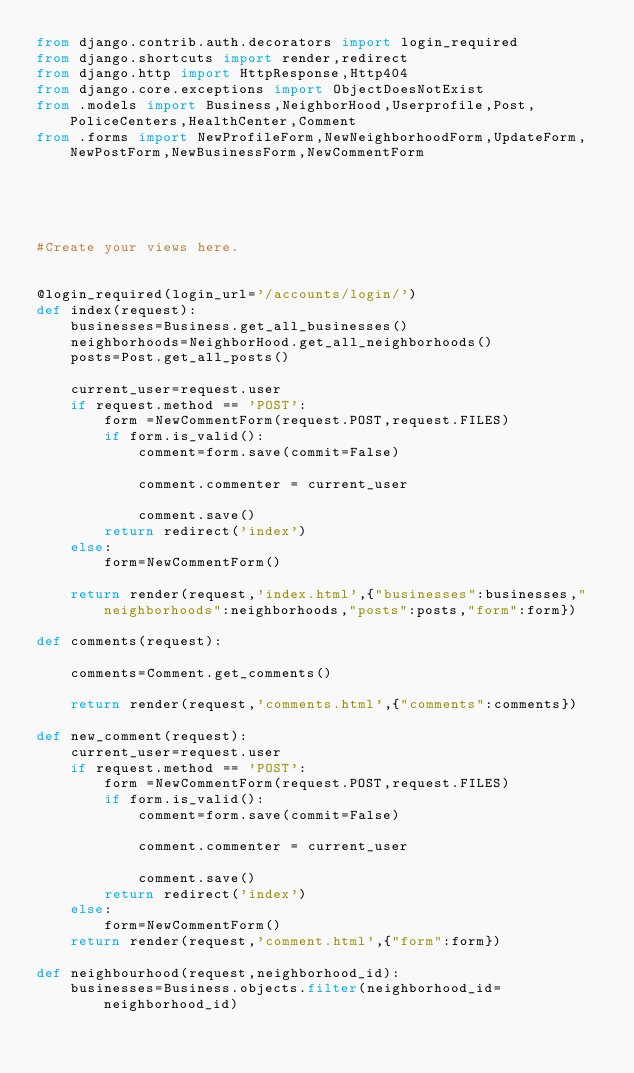<code> <loc_0><loc_0><loc_500><loc_500><_Python_>from django.contrib.auth.decorators import login_required
from django.shortcuts import render,redirect
from django.http import HttpResponse,Http404
from django.core.exceptions import ObjectDoesNotExist
from .models import Business,NeighborHood,Userprofile,Post,PoliceCenters,HealthCenter,Comment
from .forms import NewProfileForm,NewNeighborhoodForm,UpdateForm,NewPostForm,NewBusinessForm,NewCommentForm





#Create your views here.


@login_required(login_url='/accounts/login/')
def index(request):
    businesses=Business.get_all_businesses()
    neighborhoods=NeighborHood.get_all_neighborhoods()
    posts=Post.get_all_posts()

    current_user=request.user
    if request.method == 'POST':
        form =NewCommentForm(request.POST,request.FILES)
        if form.is_valid():
            comment=form.save(commit=False)

            comment.commenter = current_user

            comment.save()
        return redirect('index')
    else:
        form=NewCommentForm()

    return render(request,'index.html',{"businesses":businesses,"neighborhoods":neighborhoods,"posts":posts,"form":form})

def comments(request):

    comments=Comment.get_comments()

    return render(request,'comments.html',{"comments":comments})

def new_comment(request):
    current_user=request.user
    if request.method == 'POST':
        form =NewCommentForm(request.POST,request.FILES)
        if form.is_valid():
            comment=form.save(commit=False)

            comment.commenter = current_user

            comment.save()
        return redirect('index')
    else:
        form=NewCommentForm()
    return render(request,'comment.html',{"form":form})

def neighbourhood(request,neighborhood_id):
    businesses=Business.objects.filter(neighborhood_id=neighborhood_id)
</code> 